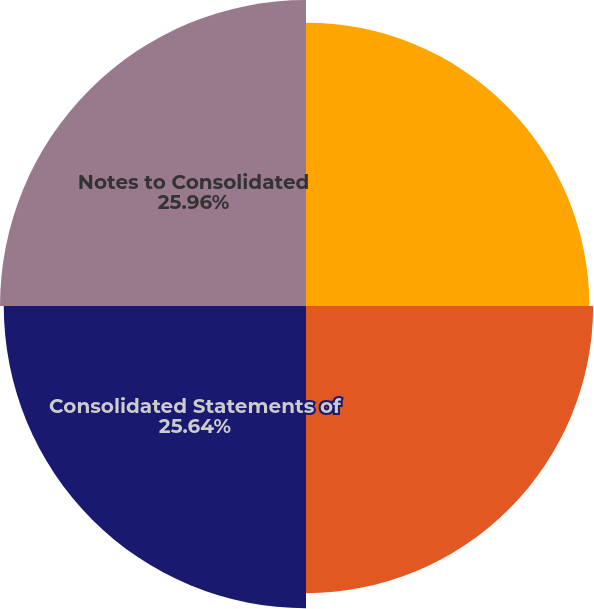Convert chart to OTSL. <chart><loc_0><loc_0><loc_500><loc_500><pie_chart><fcel>Report of Independent<fcel>Consolidated Balance Sheets<fcel>Consolidated Statements of<fcel>Notes to Consolidated<nl><fcel>24.04%<fcel>24.36%<fcel>25.64%<fcel>25.96%<nl></chart> 